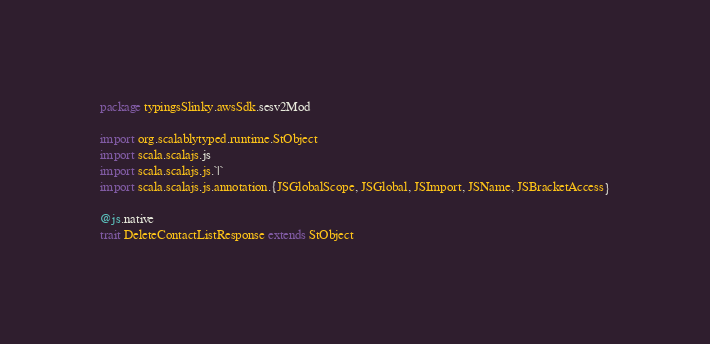Convert code to text. <code><loc_0><loc_0><loc_500><loc_500><_Scala_>package typingsSlinky.awsSdk.sesv2Mod

import org.scalablytyped.runtime.StObject
import scala.scalajs.js
import scala.scalajs.js.`|`
import scala.scalajs.js.annotation.{JSGlobalScope, JSGlobal, JSImport, JSName, JSBracketAccess}

@js.native
trait DeleteContactListResponse extends StObject
</code> 